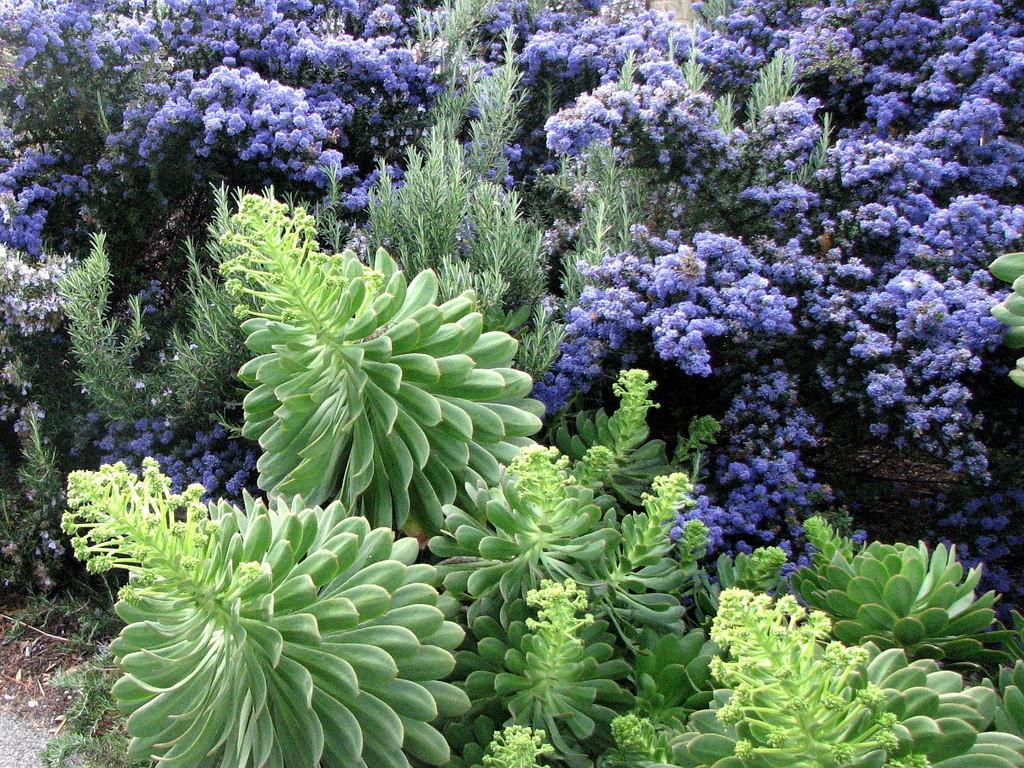Could you give a brief overview of what you see in this image? In this image there are flowers, plants and trees. 